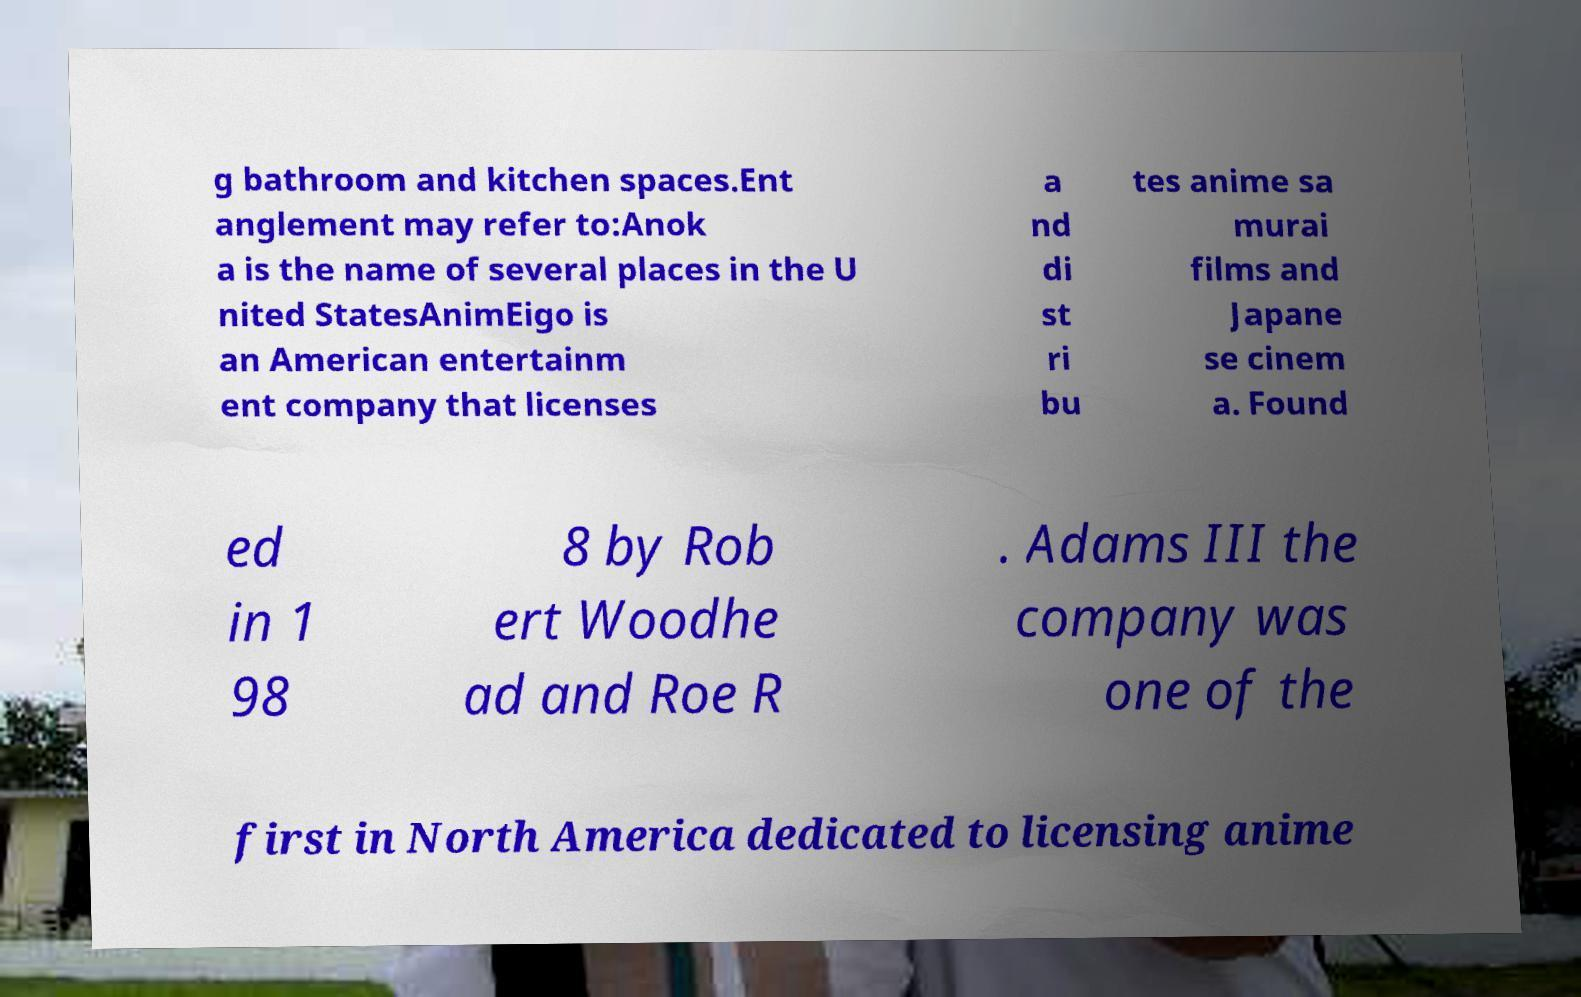Please identify and transcribe the text found in this image. g bathroom and kitchen spaces.Ent anglement may refer to:Anok a is the name of several places in the U nited StatesAnimEigo is an American entertainm ent company that licenses a nd di st ri bu tes anime sa murai films and Japane se cinem a. Found ed in 1 98 8 by Rob ert Woodhe ad and Roe R . Adams III the company was one of the first in North America dedicated to licensing anime 